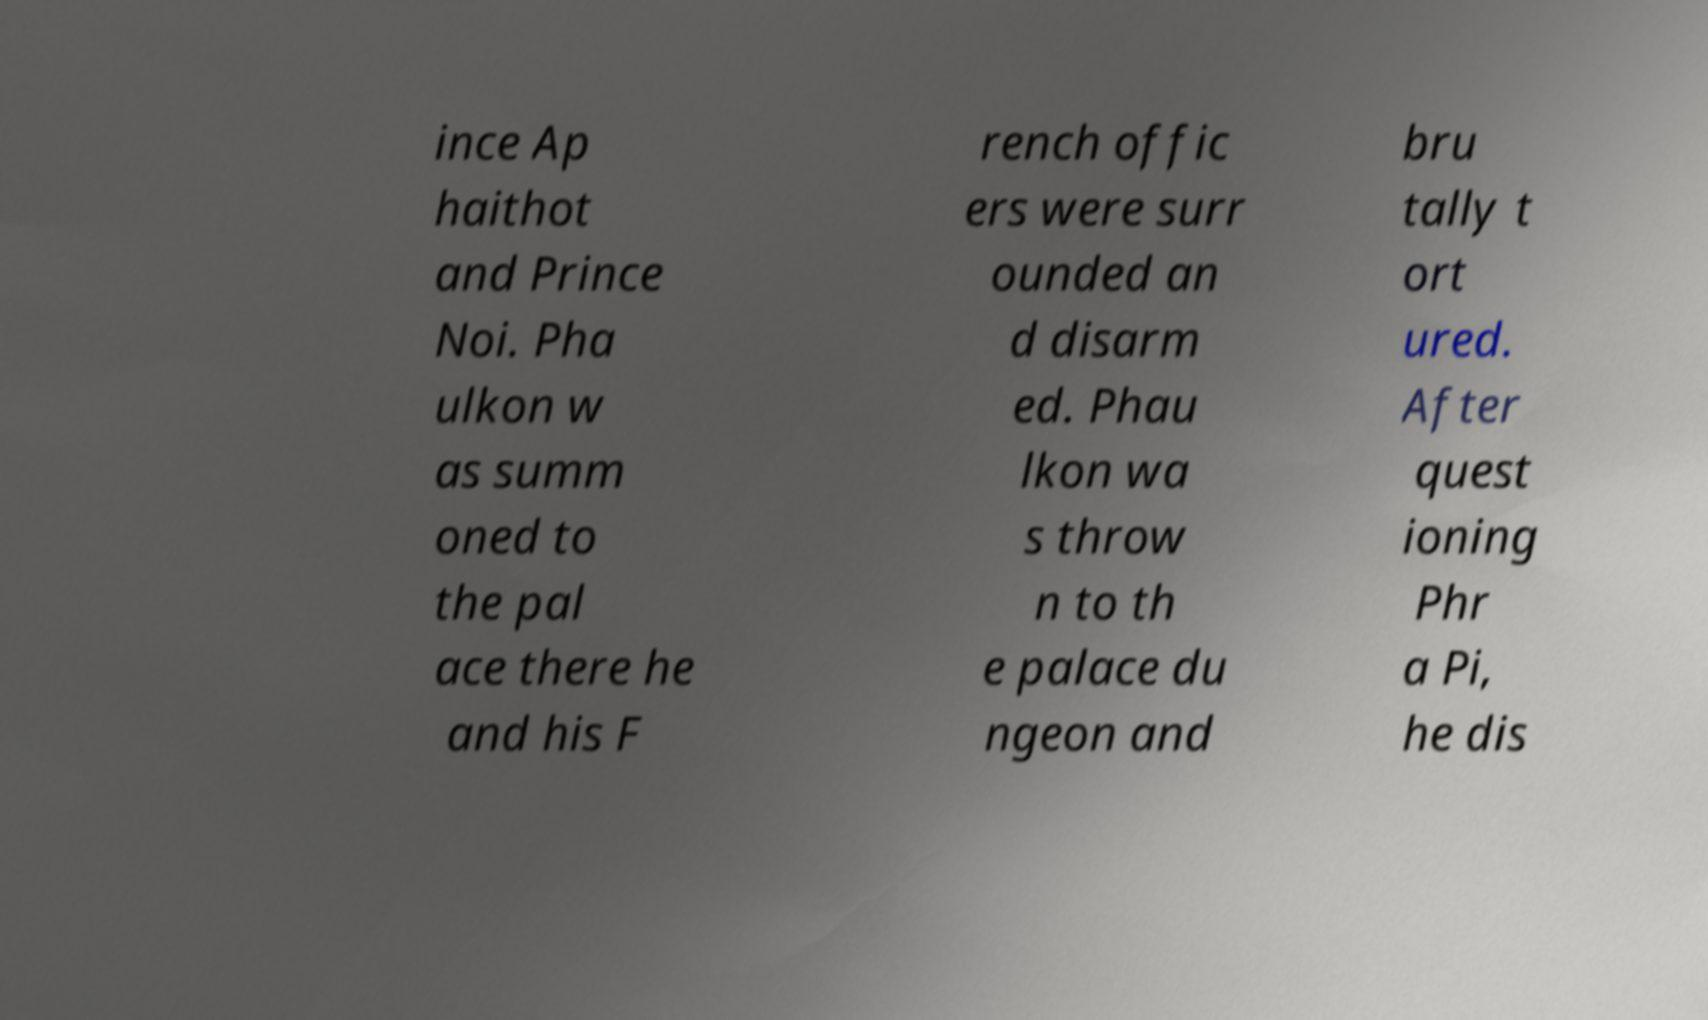Please identify and transcribe the text found in this image. ince Ap haithot and Prince Noi. Pha ulkon w as summ oned to the pal ace there he and his F rench offic ers were surr ounded an d disarm ed. Phau lkon wa s throw n to th e palace du ngeon and bru tally t ort ured. After quest ioning Phr a Pi, he dis 